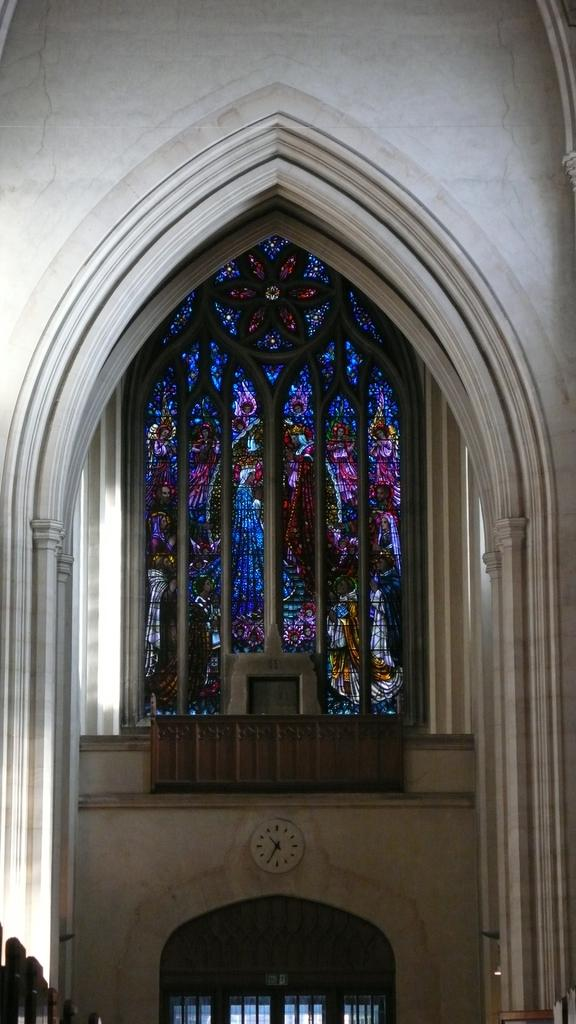What is located at the bottom of the image? There is a wall, a clock, pillars, and wooden objects at the bottom of the image. What can be found near the wall at the bottom of the image? There is a clock and pillars near the wall at the bottom of the image. What might be the wooden objects at the bottom of the image? The wooden objects at the bottom of the image could be a door or window. What is the main feature at the top of the image? The top of the image features a well. What type of window is present in the middle of the image? There is a glass window in the middle of the image. Can you tell me how many doctors are present in the image? There are no doctors present in the image. What type of rose can be seen growing near the well in the image? There are no roses present in the image. 